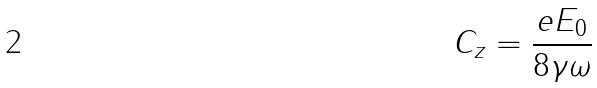Convert formula to latex. <formula><loc_0><loc_0><loc_500><loc_500>C _ { z } = \frac { e E _ { 0 } } { 8 \gamma \omega }</formula> 